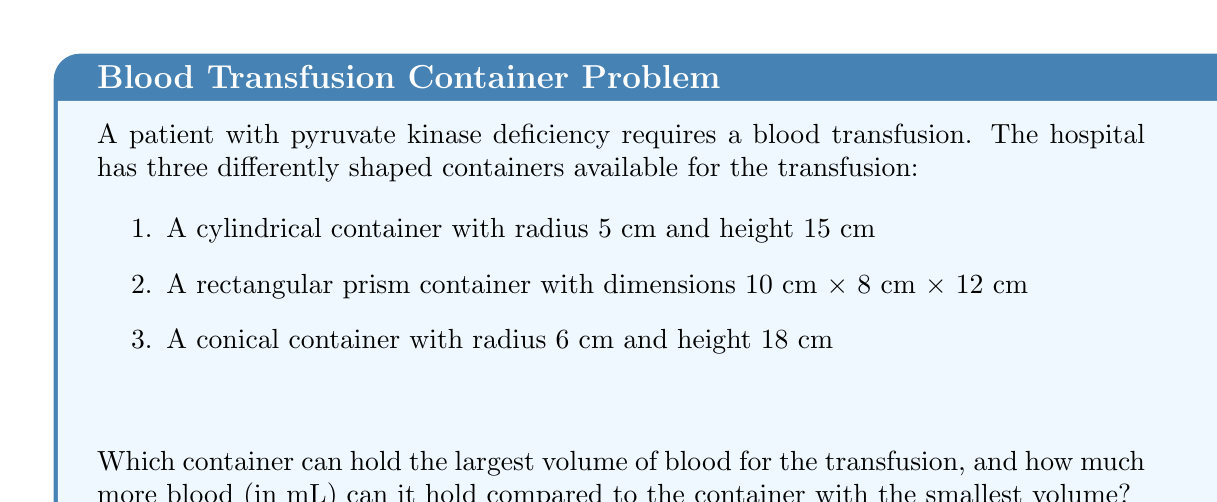Could you help me with this problem? Let's calculate the volume of each container:

1. Cylindrical container:
   $$V_c = \pi r^2 h = \pi \cdot 5^2 \cdot 15 = 1178.10 \text{ cm}^3$$

2. Rectangular prism container:
   $$V_r = l \cdot w \cdot h = 10 \cdot 8 \cdot 12 = 960 \text{ cm}^3$$

3. Conical container:
   $$V_n = \frac{1}{3} \pi r^2 h = \frac{1}{3} \pi \cdot 6^2 \cdot 18 = 678.58 \text{ cm}^3$$

The cylindrical container has the largest volume (1178.10 cm³), while the conical container has the smallest volume (678.58 cm³).

To find how much more blood the cylindrical container can hold compared to the conical container:

$$1178.10 \text{ cm}^3 - 678.58 \text{ cm}^3 = 499.52 \text{ cm}^3$$

Converting to milliliters (1 cm³ = 1 mL):

$$499.52 \text{ cm}^3 = 499.52 \text{ mL}$$

Therefore, the cylindrical container can hold 499.52 mL more blood than the conical container.
Answer: 499.52 mL 